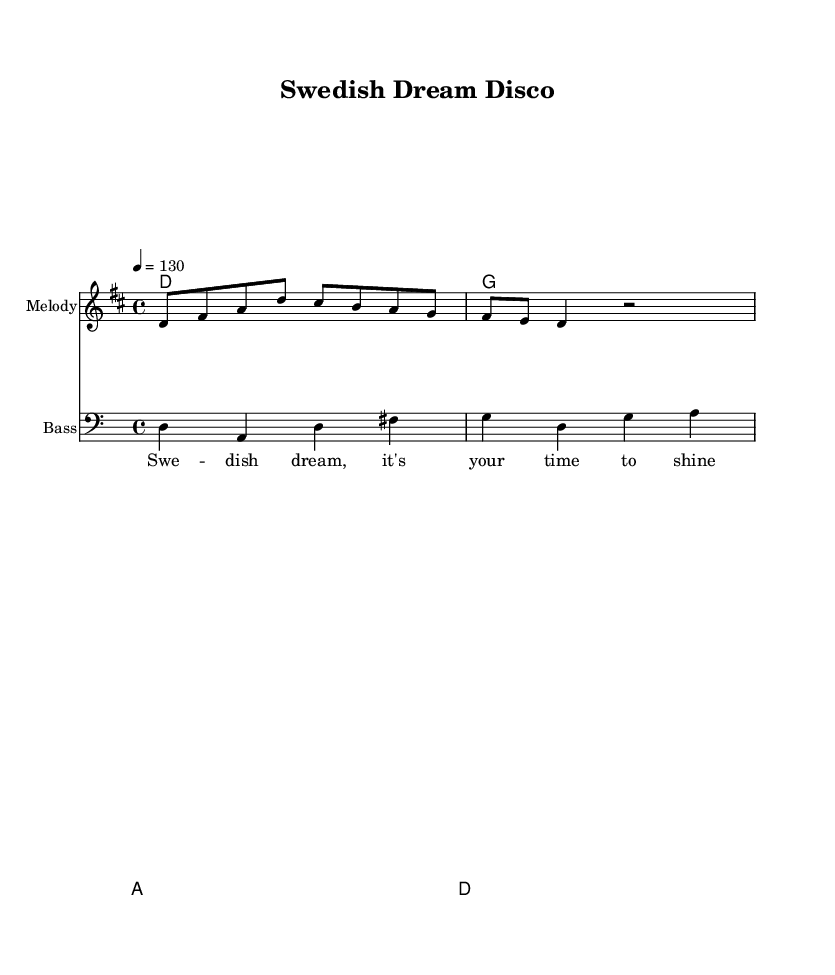What is the key signature of this music? The key signature is D major, which includes two sharps (F# and C#). This can be determined by looking at the key signature indicated at the beginning of the score, next to the time signature.
Answer: D major What is the time signature of the music? The time signature is 4/4, which means there are four beats in each measure and a quarter note gets one beat. This is indicated at the beginning of the staff with the '4/4' notation.
Answer: 4/4 What is the tempo marking of the piece? The tempo marking is 130 beats per minute, indicated in the score with the notation “\tempo 4 = 130.” This tells the performer how fast the music should be played.
Answer: 130 How many measures are in the melody section? The melody section contains three measures, which can be counted by looking at the segments of the notes separated by vertical bar lines on the staff. Each section between bar lines represents one measure.
Answer: 3 Which chord follows the D major chord in the harmony? The chord that follows the D major chord is G major, as indicated in the chord progression written below the melody line. The chords are arranged sequentially, revealing the order of harmonies played.
Answer: G What type of music is this piece classified as? This piece is classified as Disco music, indicated by its energetic tempo, upbeat rhythms, and the lyrical theme of motivation and dreams, which are characteristic elements of the disco genre.
Answer: Disco What do the lyrics suggest about the song's theme? The lyrics suggest a theme of aspiration and determination, as they emphasize shining and fulfilling one's dreams. This interpretation is derived from the content of the lyrics provided in the score.
Answer: Aspiration 